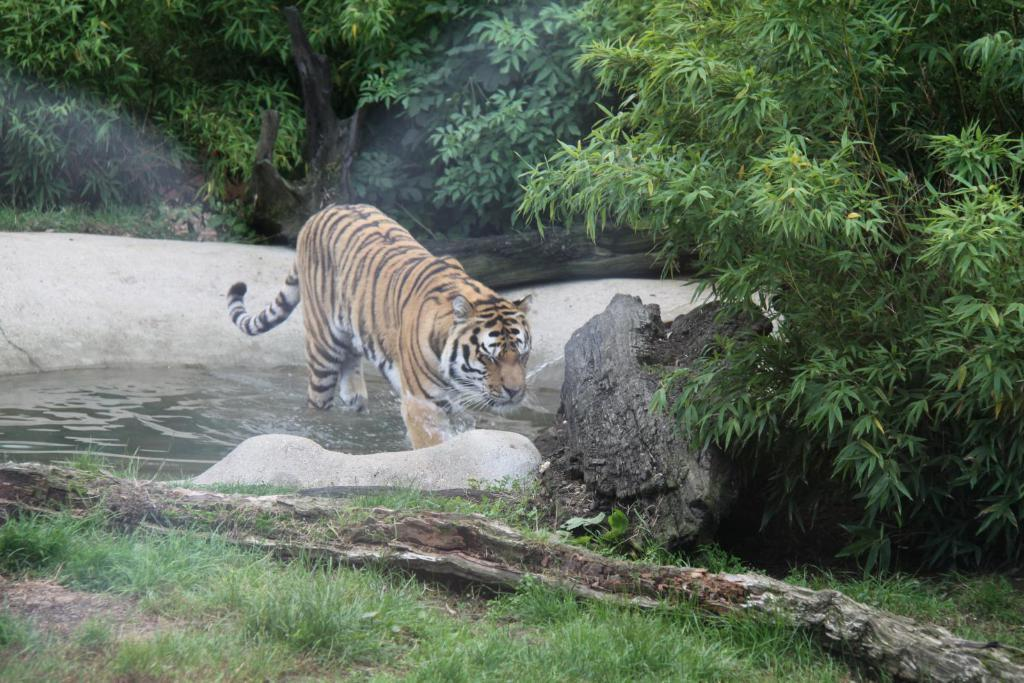What animal is standing in the water in the image? There is a tiger standing in the water in the image. What can be seen in the background of the image? There are trees visible in the background. What object is in the foreground of the image? There is a tree trunk in the foreground. What type of vegetation is present at the bottom of the image? Grass is present at the bottom of the image. What type of ink is being used by the tiger in the image? There is no ink present in the image, as it features a tiger standing in the water. How many quinces are visible in the image? There are no quinces present in the image; it features a tiger standing in the water, trees in the background, a tree trunk in the foreground, and grass at the bottom. 